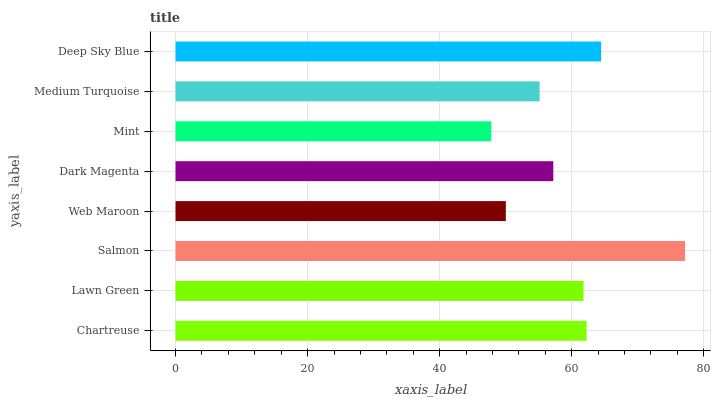Is Mint the minimum?
Answer yes or no. Yes. Is Salmon the maximum?
Answer yes or no. Yes. Is Lawn Green the minimum?
Answer yes or no. No. Is Lawn Green the maximum?
Answer yes or no. No. Is Chartreuse greater than Lawn Green?
Answer yes or no. Yes. Is Lawn Green less than Chartreuse?
Answer yes or no. Yes. Is Lawn Green greater than Chartreuse?
Answer yes or no. No. Is Chartreuse less than Lawn Green?
Answer yes or no. No. Is Lawn Green the high median?
Answer yes or no. Yes. Is Dark Magenta the low median?
Answer yes or no. Yes. Is Dark Magenta the high median?
Answer yes or no. No. Is Web Maroon the low median?
Answer yes or no. No. 